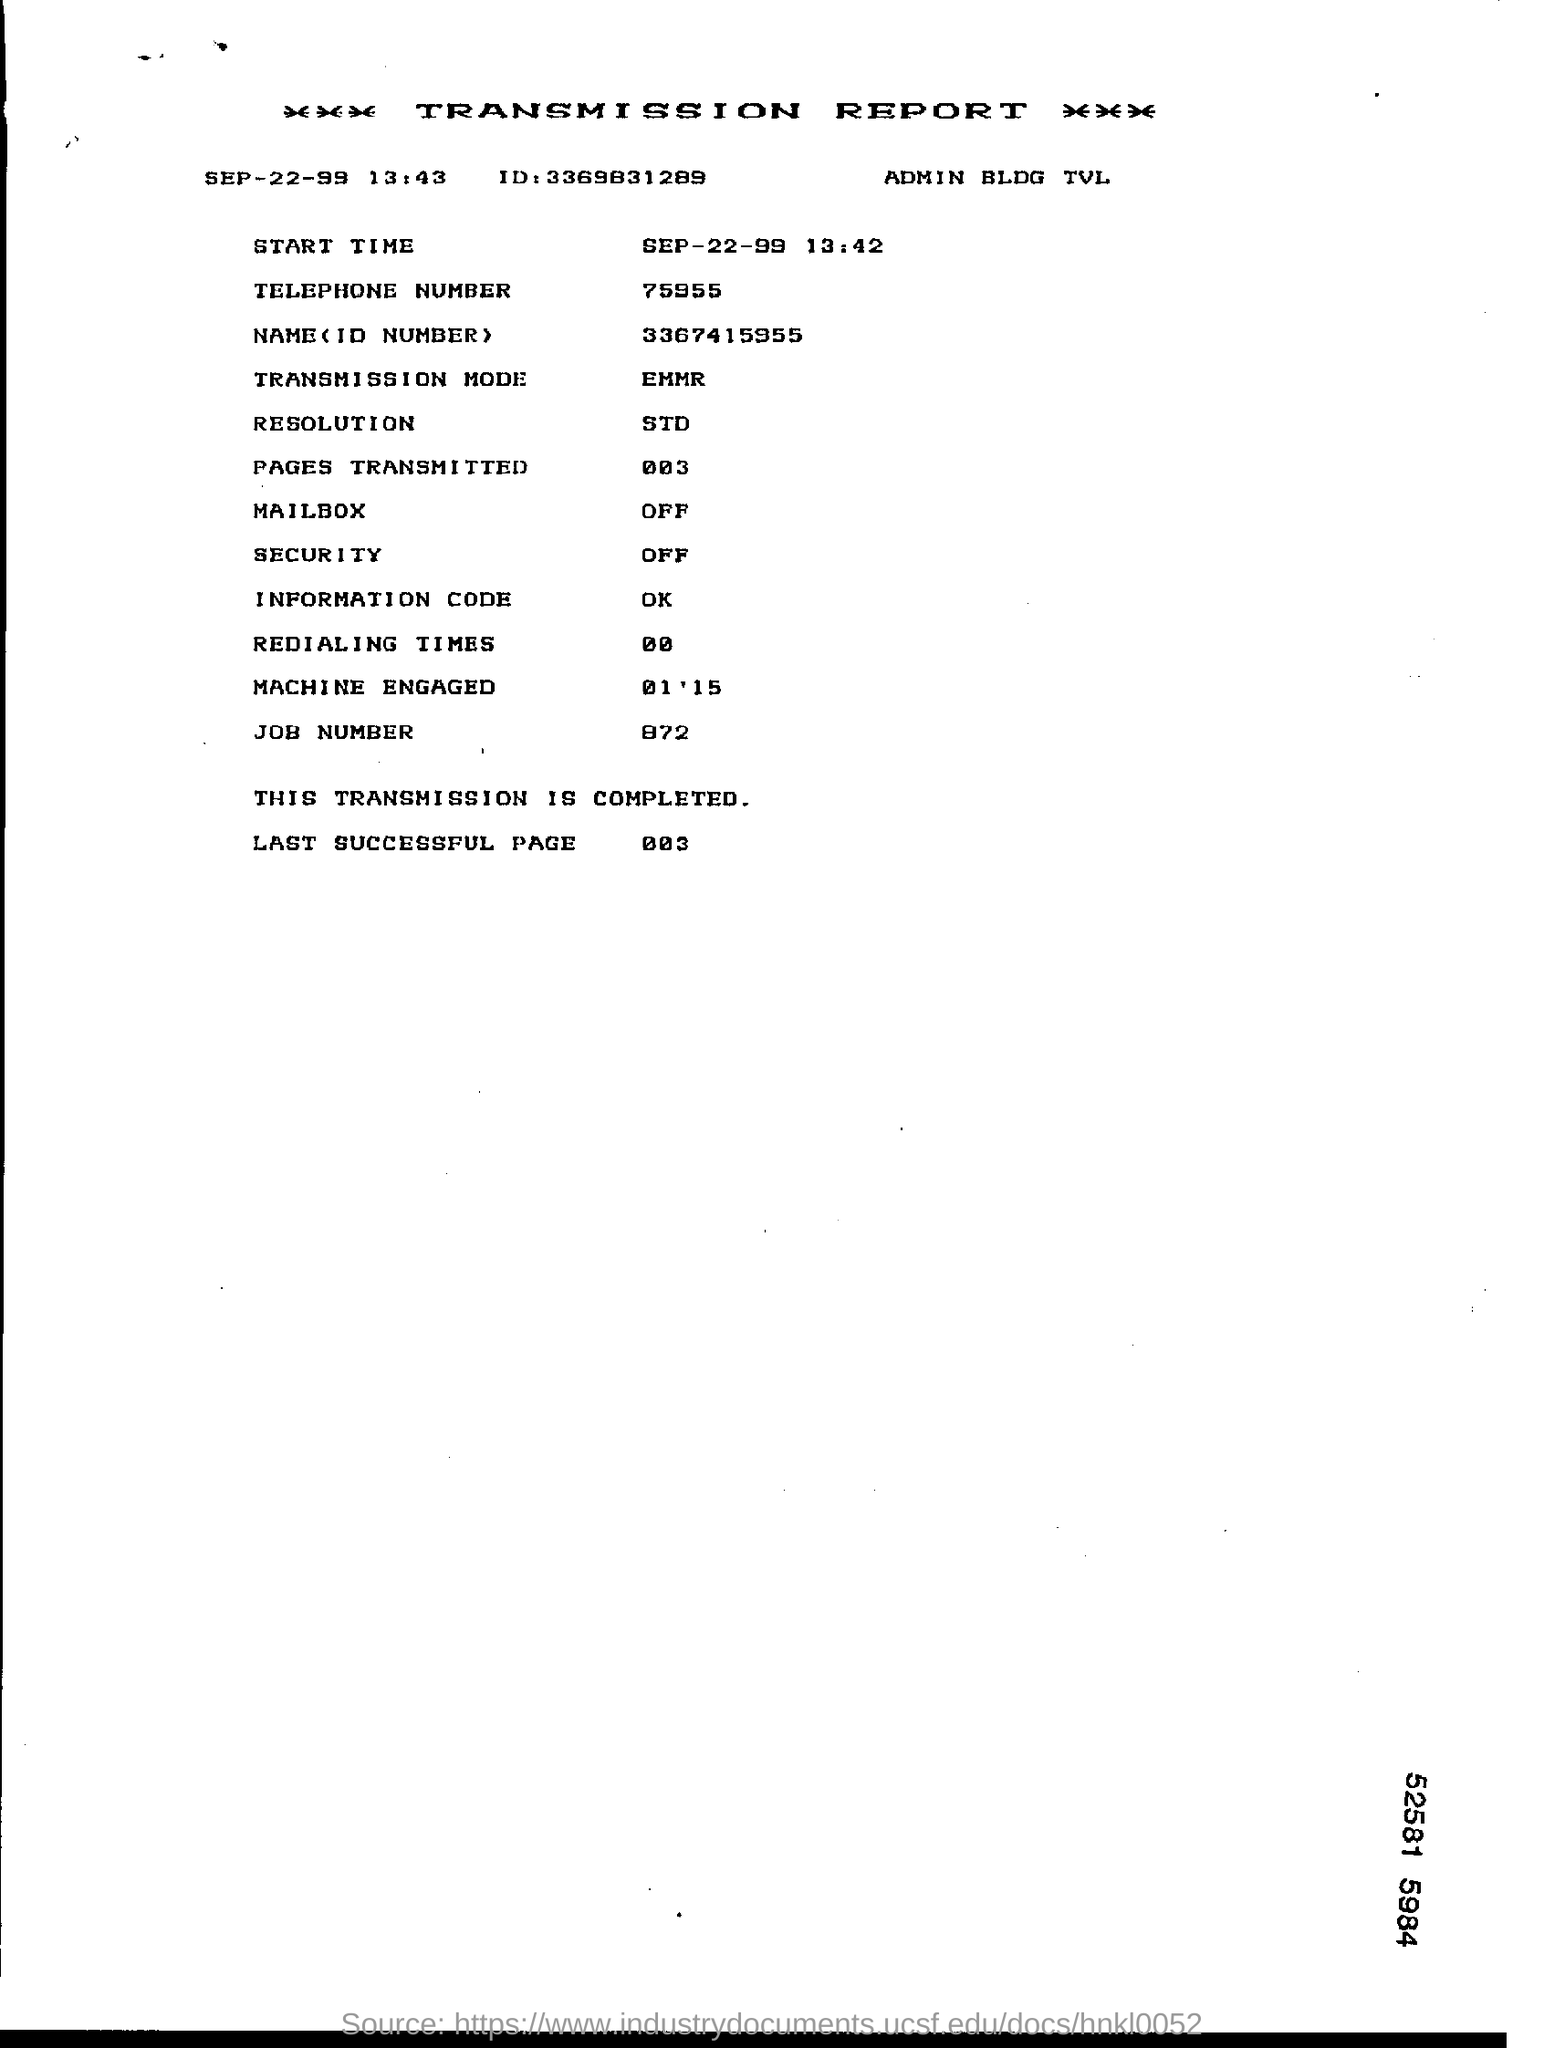Indicate a few pertinent items in this graphic. The telephone number mentioned in the report is 75955.. The job number is 872. 